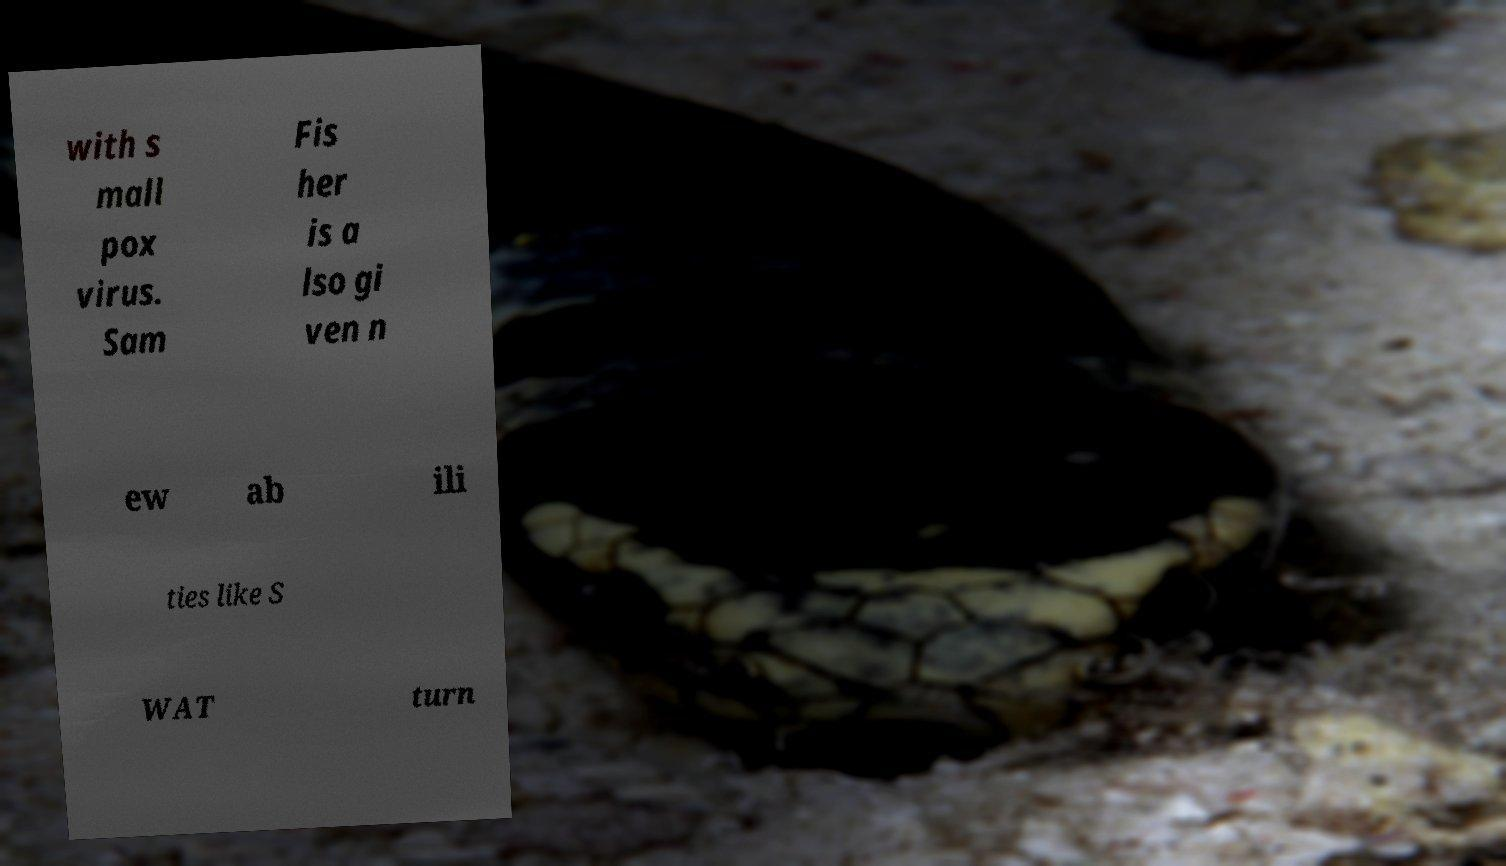Please read and relay the text visible in this image. What does it say? with s mall pox virus. Sam Fis her is a lso gi ven n ew ab ili ties like S WAT turn 